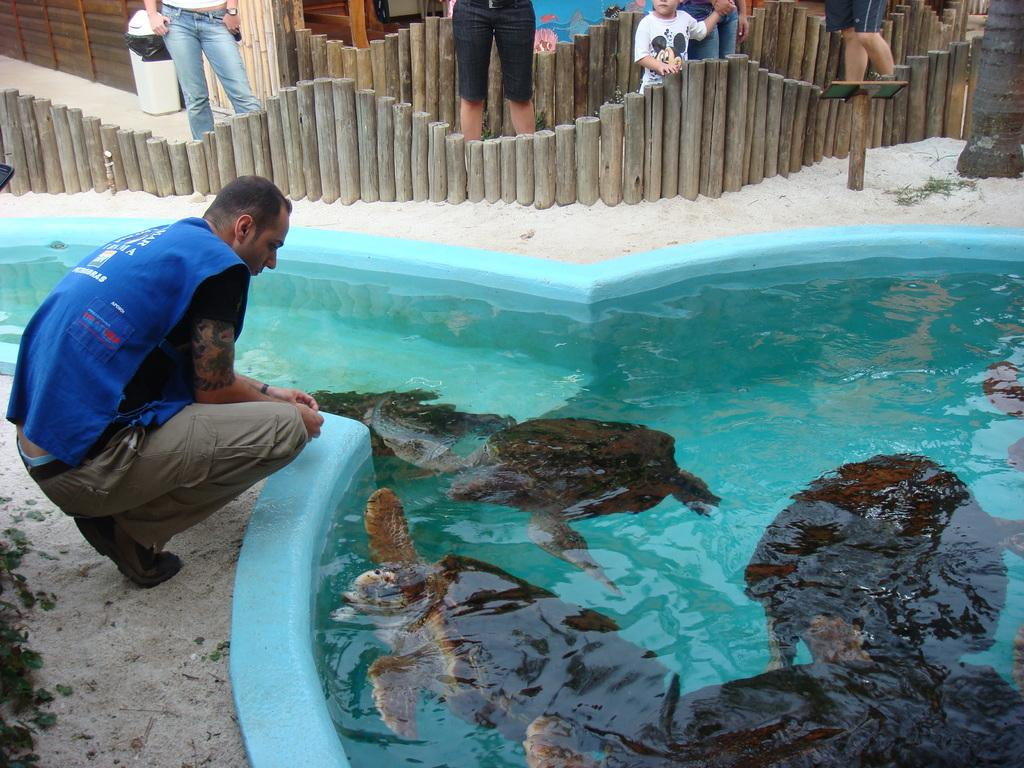What type of animals are in the water in the image? There are tortoises in the water in the image. What is the man in the image doing? The man is in a squat position on the ground. What can be seen in the background of the image? There are people standing in the background, as well as a bin and a wall. What type of oil is being used by the writer in the image? There is no writer or oil present in the image. What type of street can be seen in the image? There is no street visible in the image. 